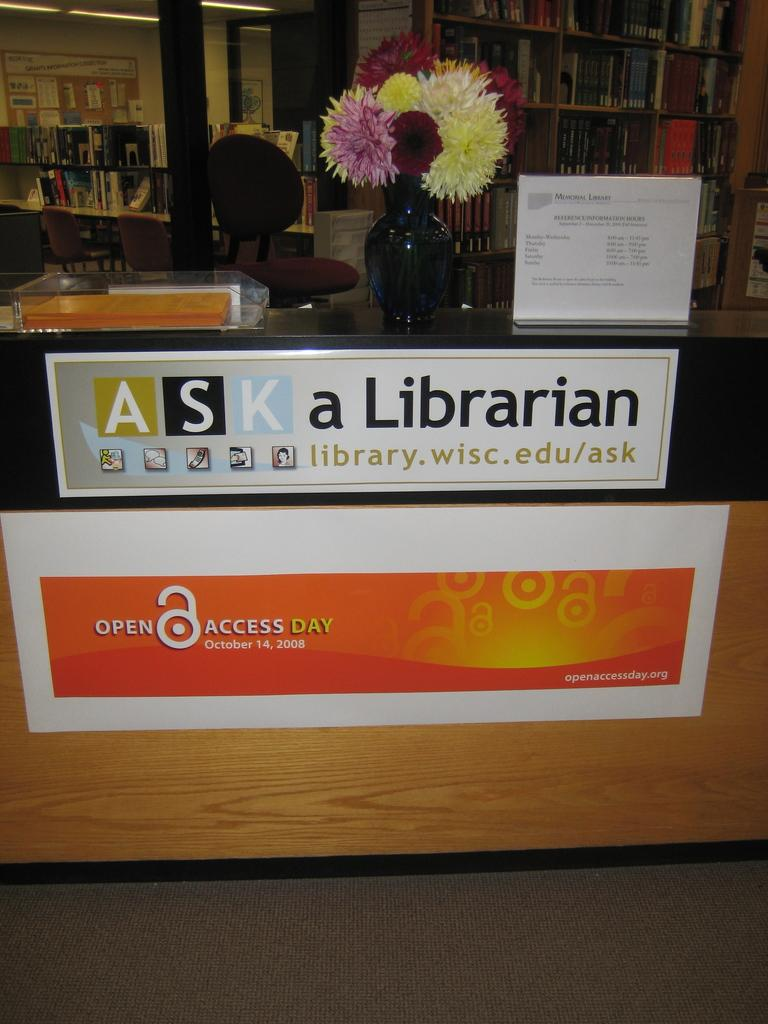<image>
Write a terse but informative summary of the picture. Front desk with a vase of flowers and a sign that says Ask a Librarian. 